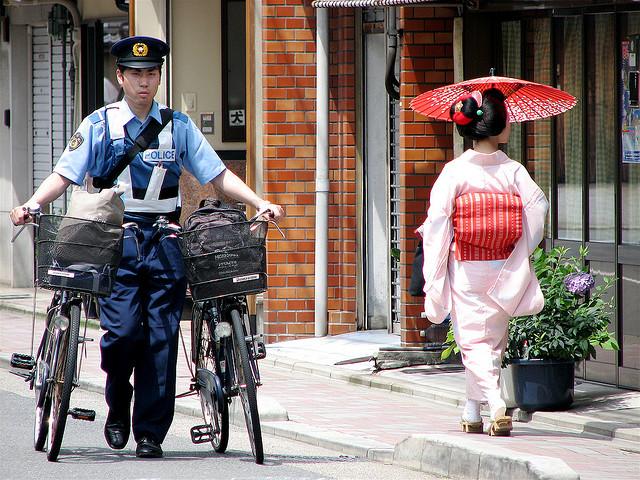What else is visible?
Answer briefly. Umbrella. Is this photo in America?
Quick response, please. No. How many bikes does the police have?
Give a very brief answer. 2. 